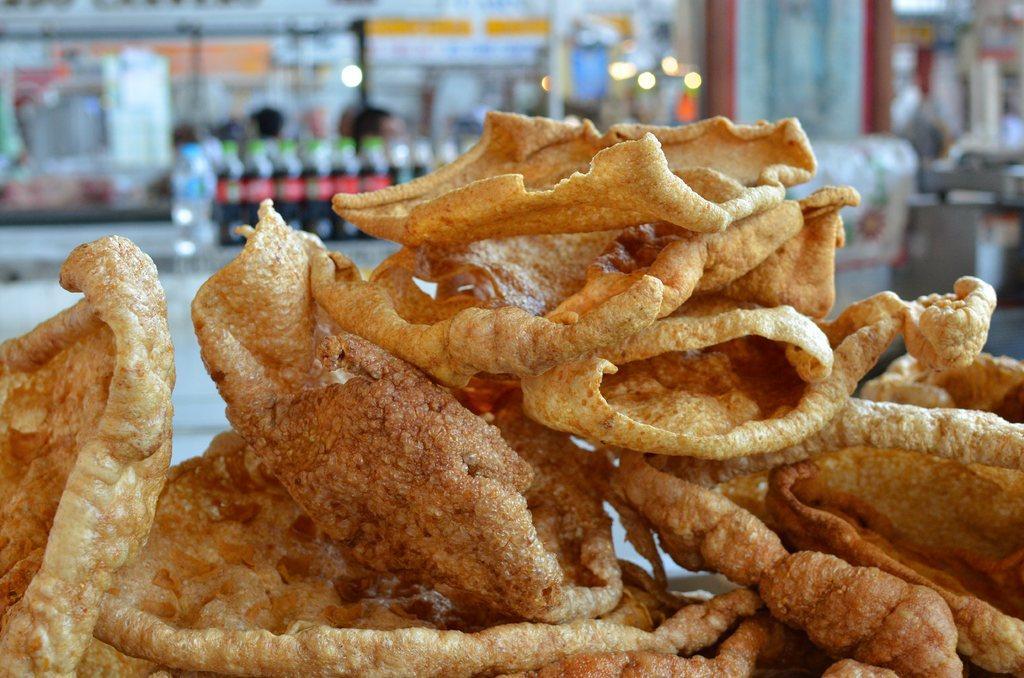In one or two sentences, can you explain what this image depicts? This image consists of fries in brown color. In the background, there are cool drink bottles. It looks like a restaurant. And the background is blurred. 